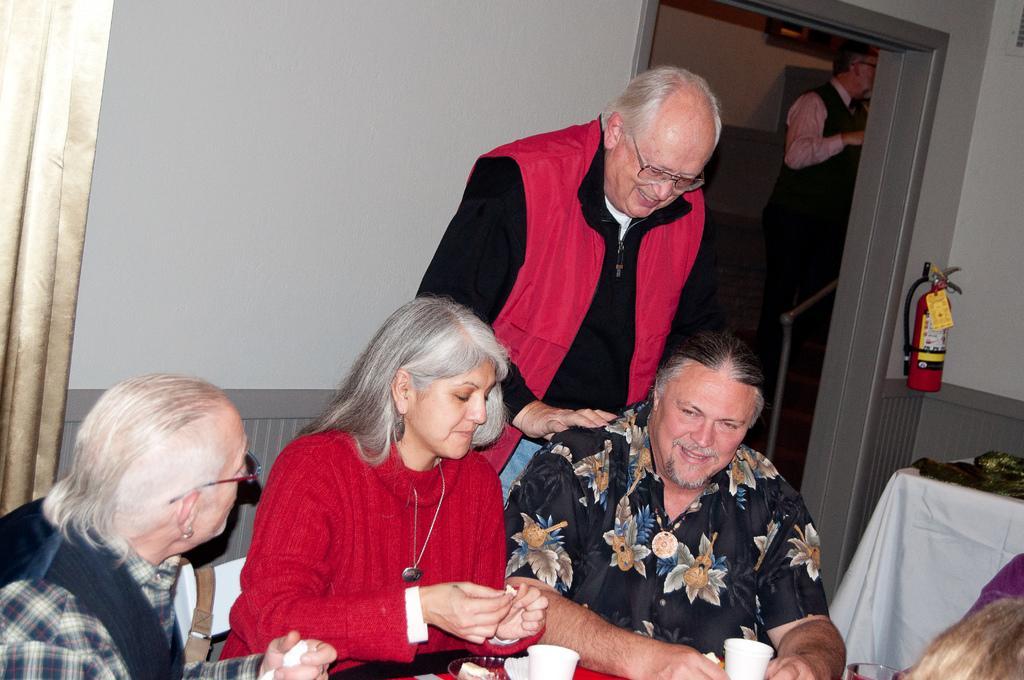In one or two sentences, can you explain what this image depicts? In this picture I can see three persons sitting, two persons standing, there is an oxygen cylinder, there is a bowl, paper cups and some other items on the tables, there is a curtain and a wall. 